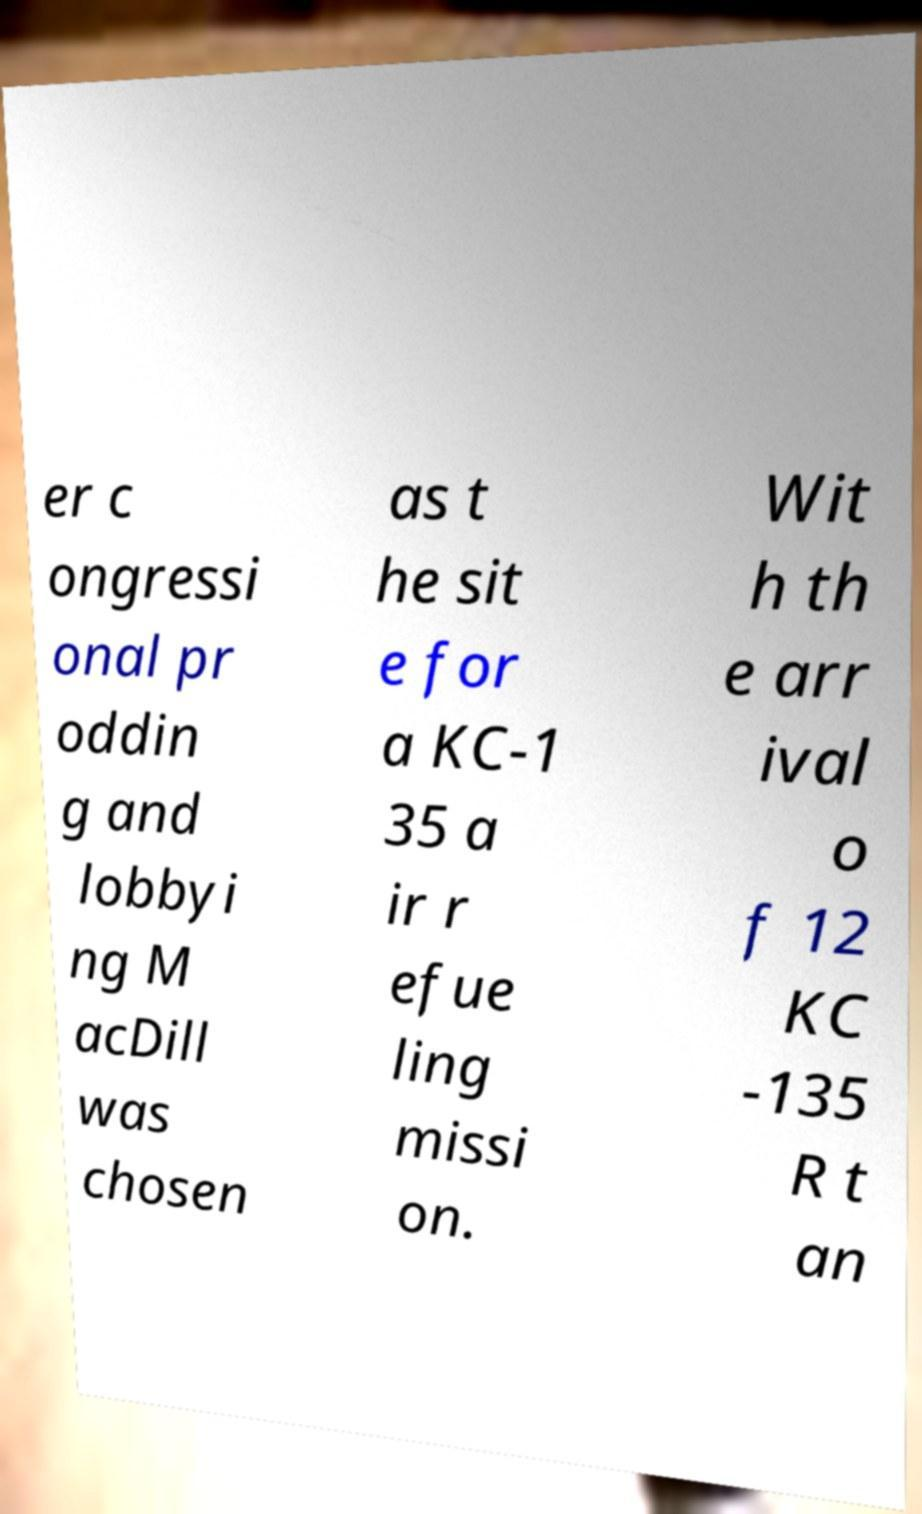There's text embedded in this image that I need extracted. Can you transcribe it verbatim? er c ongressi onal pr oddin g and lobbyi ng M acDill was chosen as t he sit e for a KC-1 35 a ir r efue ling missi on. Wit h th e arr ival o f 12 KC -135 R t an 